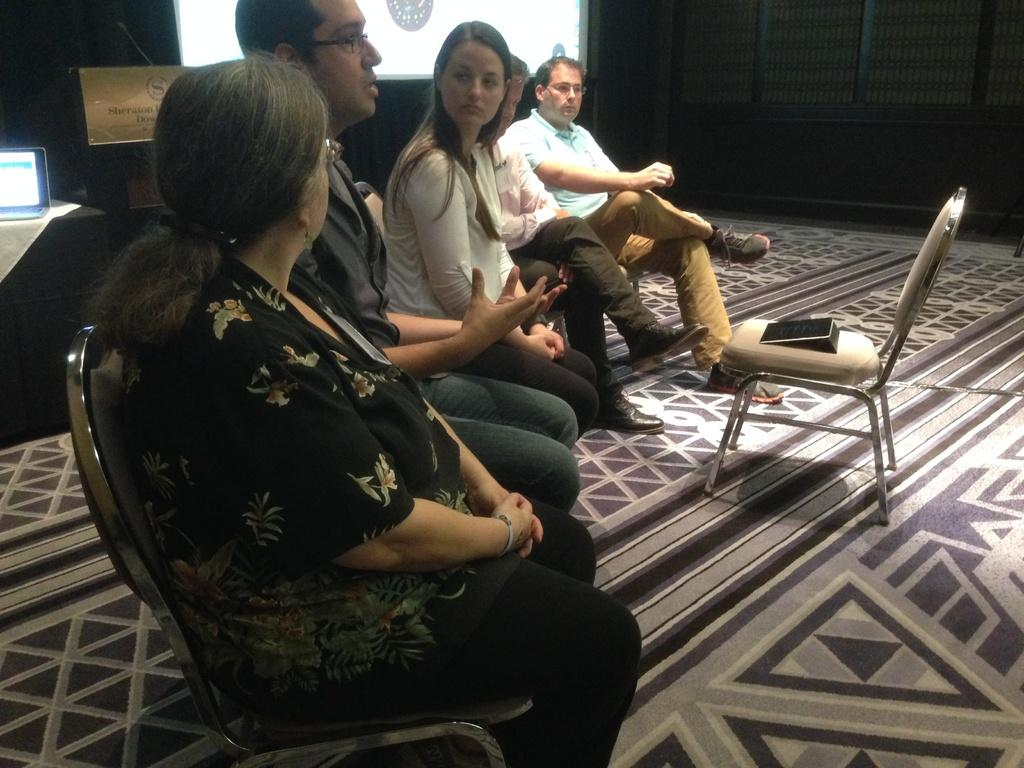How many people are in the image? There is a group of people in the image. What are the people doing in the image? The people are sitting on chairs. Is there a chair in front of the group? Yes, there is a chair in front of the group. What can be seen in the background of the image? There is a laptop and a screen in the background of the image. What letters are the people requesting in the image? There is no mention of letters or requests in the image; the people are simply sitting on chairs. 